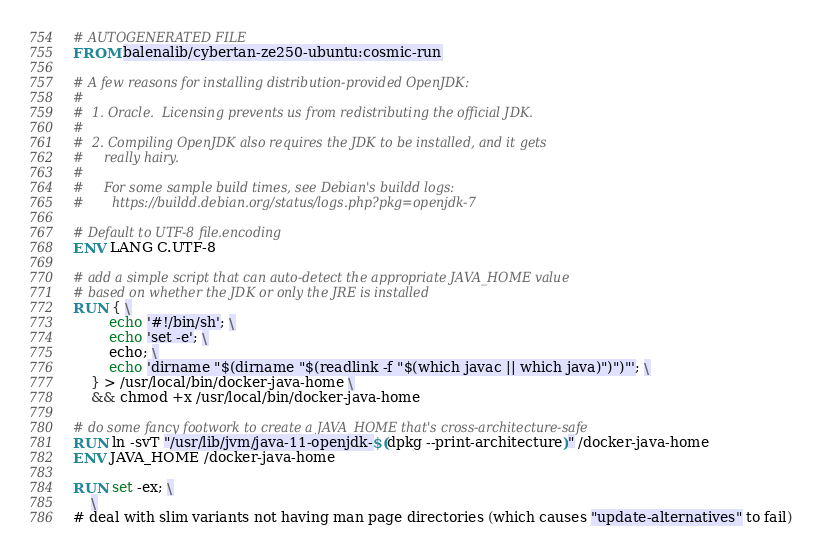<code> <loc_0><loc_0><loc_500><loc_500><_Dockerfile_># AUTOGENERATED FILE
FROM balenalib/cybertan-ze250-ubuntu:cosmic-run

# A few reasons for installing distribution-provided OpenJDK:
#
#  1. Oracle.  Licensing prevents us from redistributing the official JDK.
#
#  2. Compiling OpenJDK also requires the JDK to be installed, and it gets
#     really hairy.
#
#     For some sample build times, see Debian's buildd logs:
#       https://buildd.debian.org/status/logs.php?pkg=openjdk-7

# Default to UTF-8 file.encoding
ENV LANG C.UTF-8

# add a simple script that can auto-detect the appropriate JAVA_HOME value
# based on whether the JDK or only the JRE is installed
RUN { \
		echo '#!/bin/sh'; \
		echo 'set -e'; \
		echo; \
		echo 'dirname "$(dirname "$(readlink -f "$(which javac || which java)")")"'; \
	} > /usr/local/bin/docker-java-home \
	&& chmod +x /usr/local/bin/docker-java-home

# do some fancy footwork to create a JAVA_HOME that's cross-architecture-safe
RUN ln -svT "/usr/lib/jvm/java-11-openjdk-$(dpkg --print-architecture)" /docker-java-home
ENV JAVA_HOME /docker-java-home

RUN set -ex; \
	\
# deal with slim variants not having man page directories (which causes "update-alternatives" to fail)</code> 